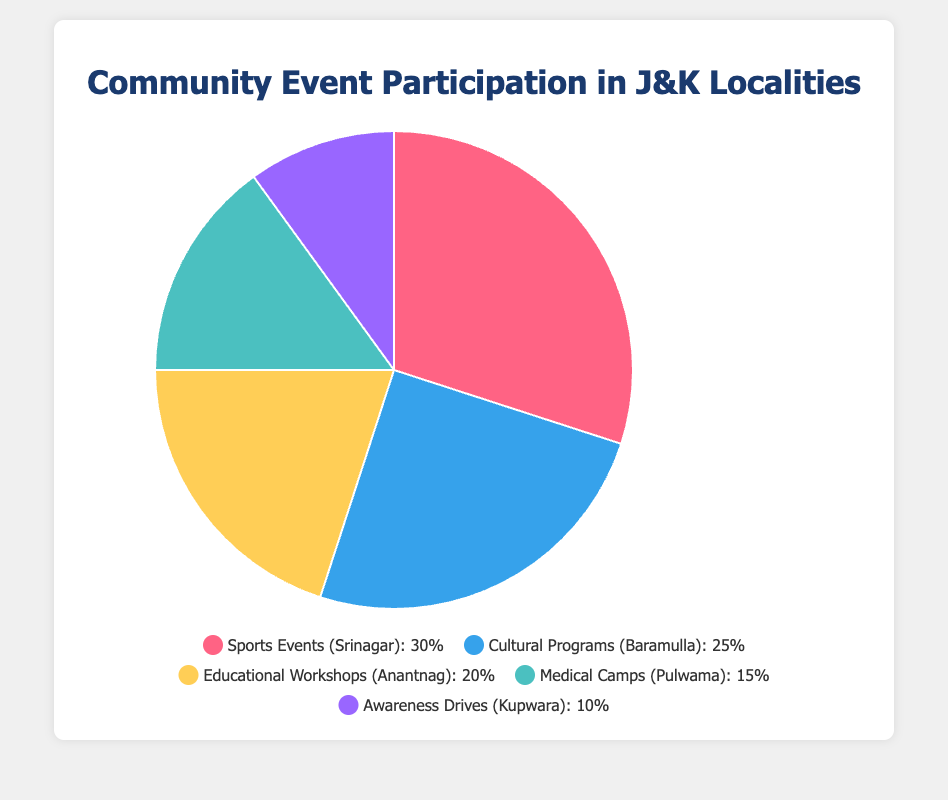What percentage of total participation is from Sports Events and Cultural Programs? To find the total percentage participation from Sports Events and Cultural Programs, add the percentages from both categories: 30% (Sports Events) + 25% (Cultural Programs) = 55%.
Answer: 55% How much greater is the participation in Sports Events compared to Awareness Drives? Compare the percentages: 30% (Sports Events) - 10% (Awareness Drives) = 20%.
Answer: 20% Which locality has the highest participation in community events? Among the given localities, Srinagar has the highest participation at 30% (Sports Events).
Answer: Srinagar What is the average participation percentage across all the localities? To find the average, sum the percentages and divide by the number of data points: (30 + 25 + 20 + 15 + 10)/5 = 100/5 = 20%.
Answer: 20% If you combine participation from Medical Camps and Awareness Drives, how much more or less will it be compared to Educational Workshops? Sum the percentages from Medical Camps and Awareness Drives: 15% + 10% = 25%. Compare this to Educational Workshops 20%. The combined value is 5% more.
Answer: 5% Which category of events falls in the middle when the percentages are arranged in descending order? Arrange the percentages in descending order: 30%, 25%, 20%, 15%, 10%. The middle value is 20%, which corresponds to Educational Workshops.
Answer: Educational Workshops Are there more localities with participation percentages higher or lower than 20%? Three localities have higher participation (30% Sports Events, 25% Cultural Programs, 20% Educational Workshops), and two localities have lower participation (15% Medical Camps, 10% Awareness Drives). So, more localities have higher participation.
Answer: Higher Which category is represented by the blue color in the pie chart? Referring to the visual attributes, the blue color represents Cultural Programs, as inferred from the Chart.js configuration.
Answer: Cultural Programs 